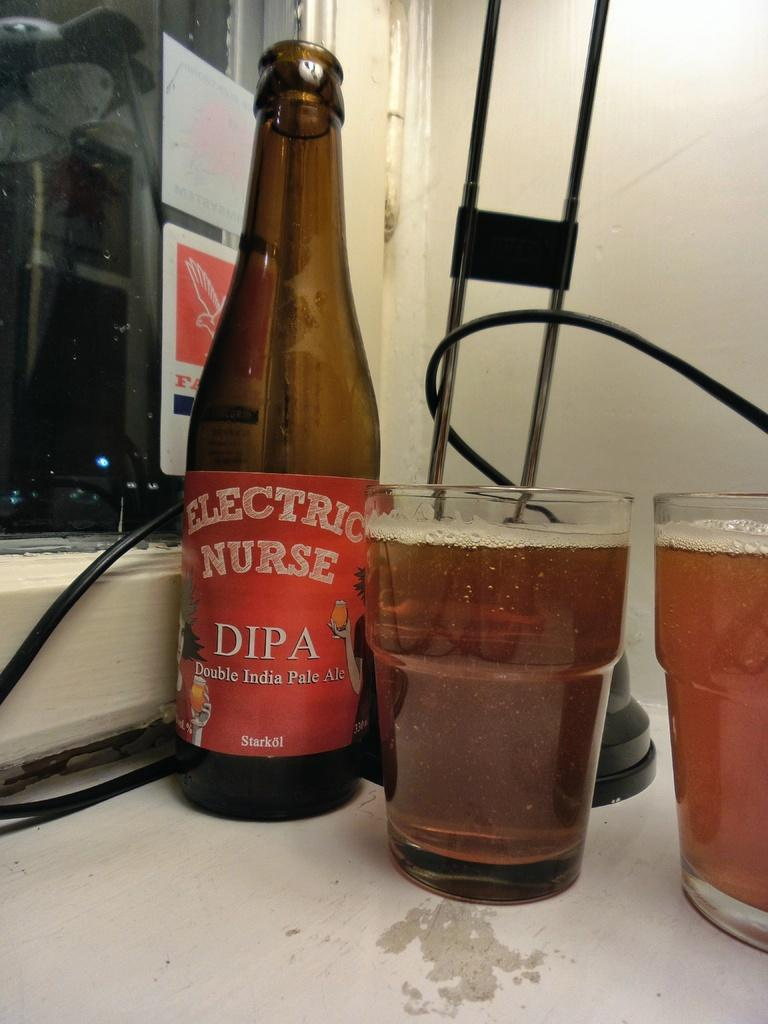Provide a one-sentence caption for the provided image. An Electric Nurse Double IPA bottle sits next to two full glasses. 